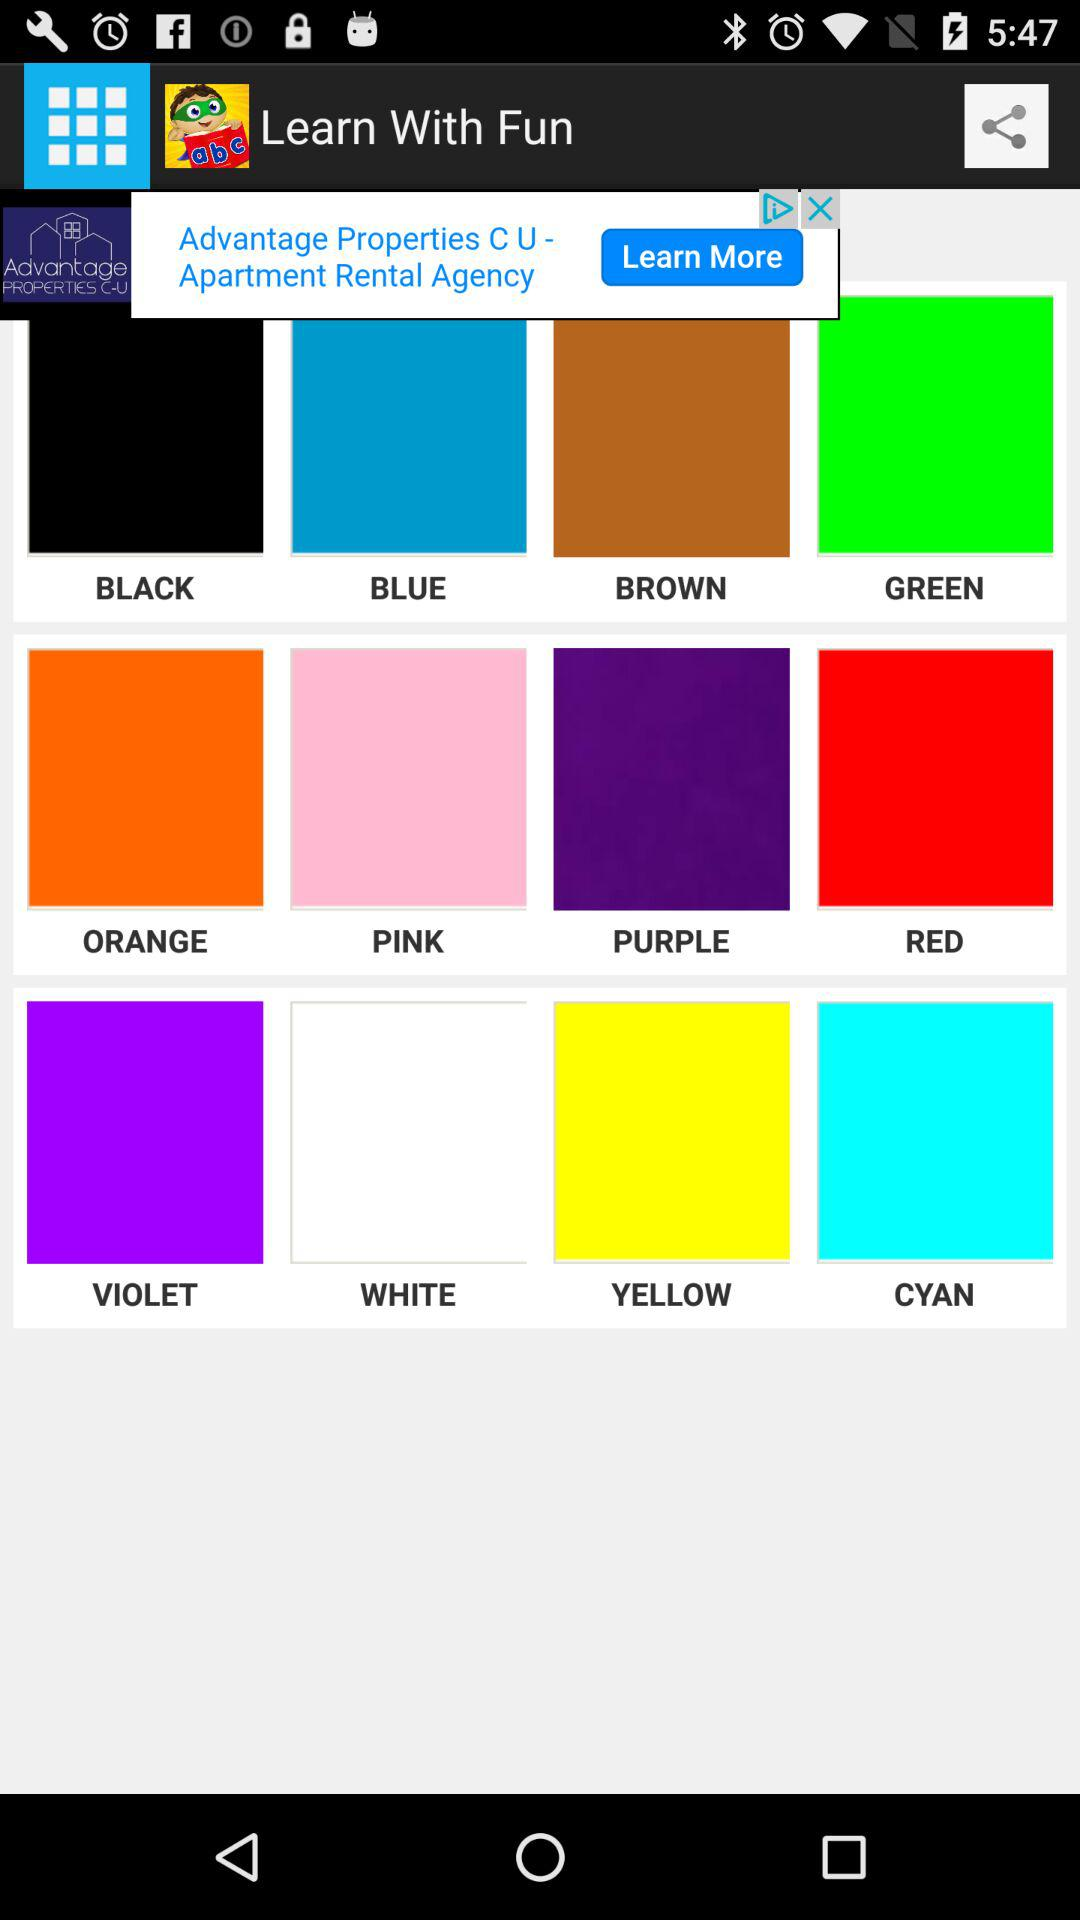What is the application name? The application name is "Learn With Fun". 